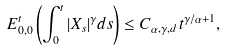<formula> <loc_0><loc_0><loc_500><loc_500>E _ { 0 , 0 } ^ { t } \left ( \int _ { 0 } ^ { t } | X _ { s } | ^ { \gamma } d s \right ) \leq C _ { \alpha , \gamma , d } \, t ^ { \gamma / \alpha + 1 } ,</formula> 